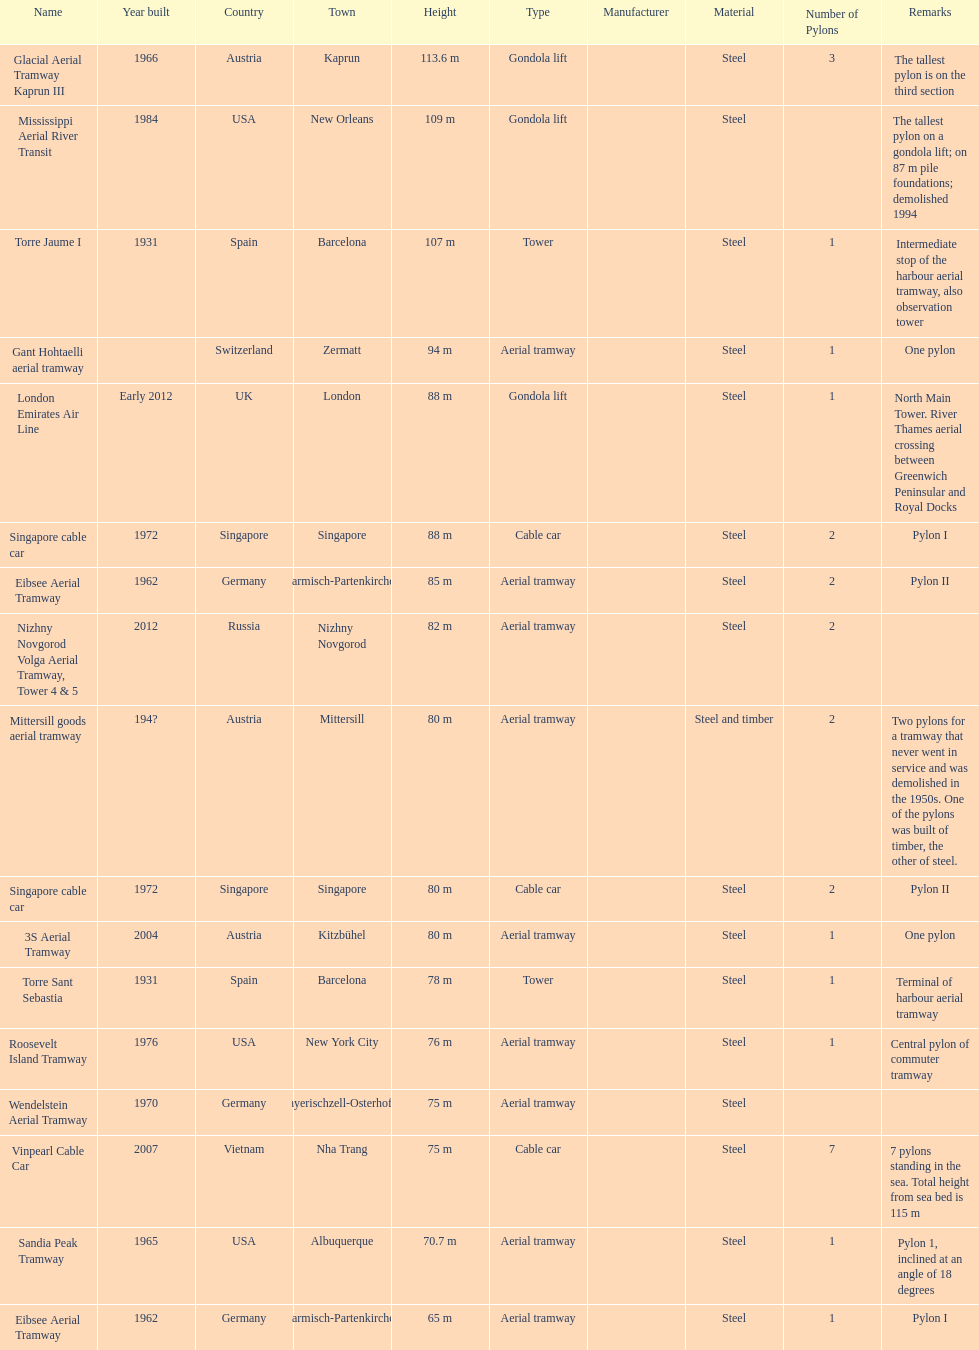Which pylon has the most remarks about it? Mittersill goods aerial tramway. 